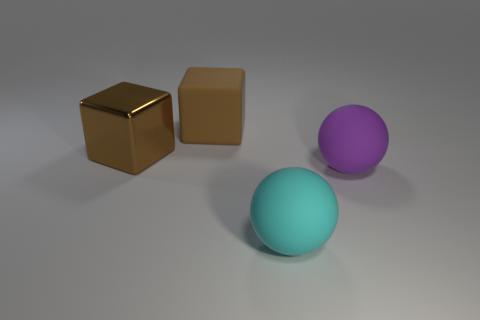Do the ball in front of the purple rubber object and the cube right of the brown metallic object have the same material? Yes, both the ball in front of the purple object and the cube to the right of the brown metallic object appear to have a similar glossy finish, suggesting they are made of similar materials, possibly a type of polished synthetic or painted metal. 